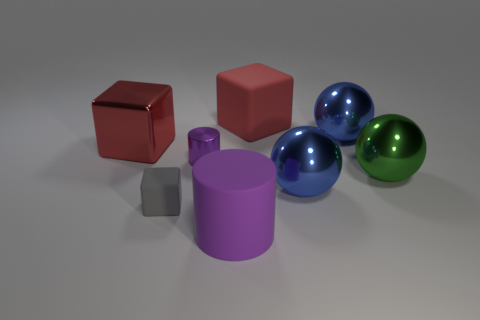There is a rubber cube in front of the blue shiny ball on the left side of the sphere that is behind the green object; what is its color?
Your answer should be very brief. Gray. Does the large metallic thing behind the big metal cube have the same color as the big metallic sphere that is in front of the green sphere?
Offer a terse response. Yes. Is there any other thing that is the same color as the big cylinder?
Your answer should be very brief. Yes. Is the number of purple matte cylinders in front of the green metallic sphere less than the number of small blocks?
Keep it short and to the point. No. How many big green metallic spheres are there?
Give a very brief answer. 1. Do the tiny rubber thing and the big rubber object in front of the shiny cylinder have the same shape?
Provide a short and direct response. No. Is the number of small metal objects that are in front of the tiny shiny thing less than the number of red things to the left of the large green shiny thing?
Your answer should be compact. Yes. Is the shape of the green thing the same as the red shiny object?
Ensure brevity in your answer.  No. What is the size of the gray matte object?
Make the answer very short. Small. There is a object that is both to the left of the red rubber object and behind the metallic cylinder; what color is it?
Offer a very short reply. Red. 